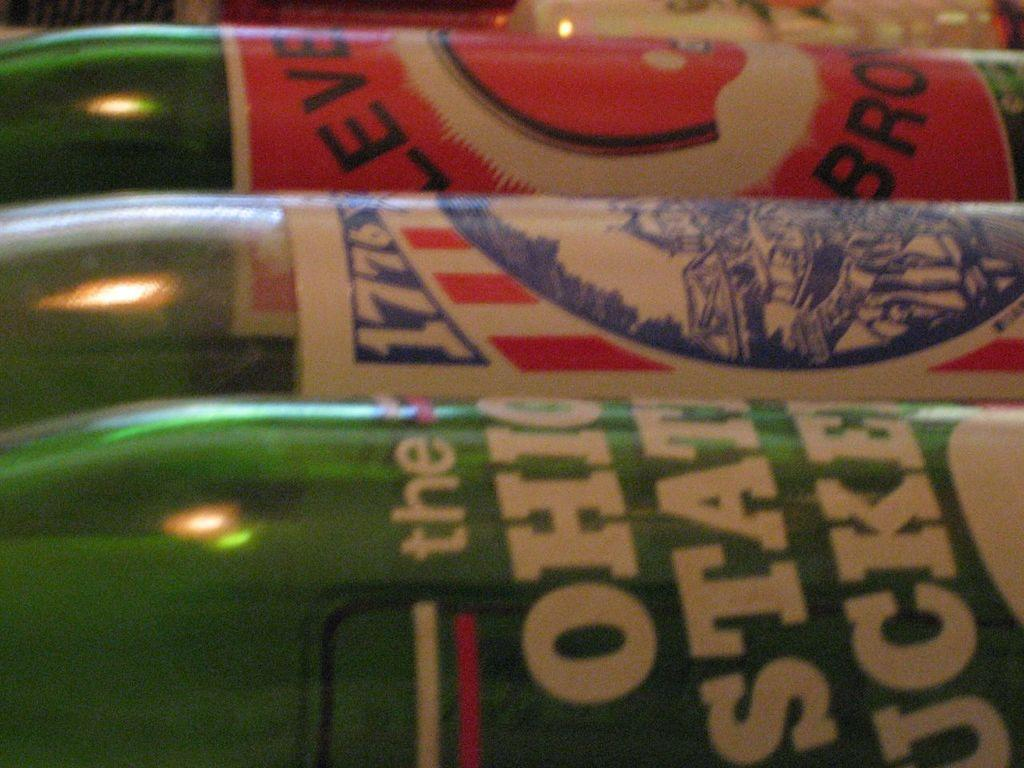<image>
Provide a brief description of the given image. A bottle's label has the date 1776 printed on it, between two other bottles. 